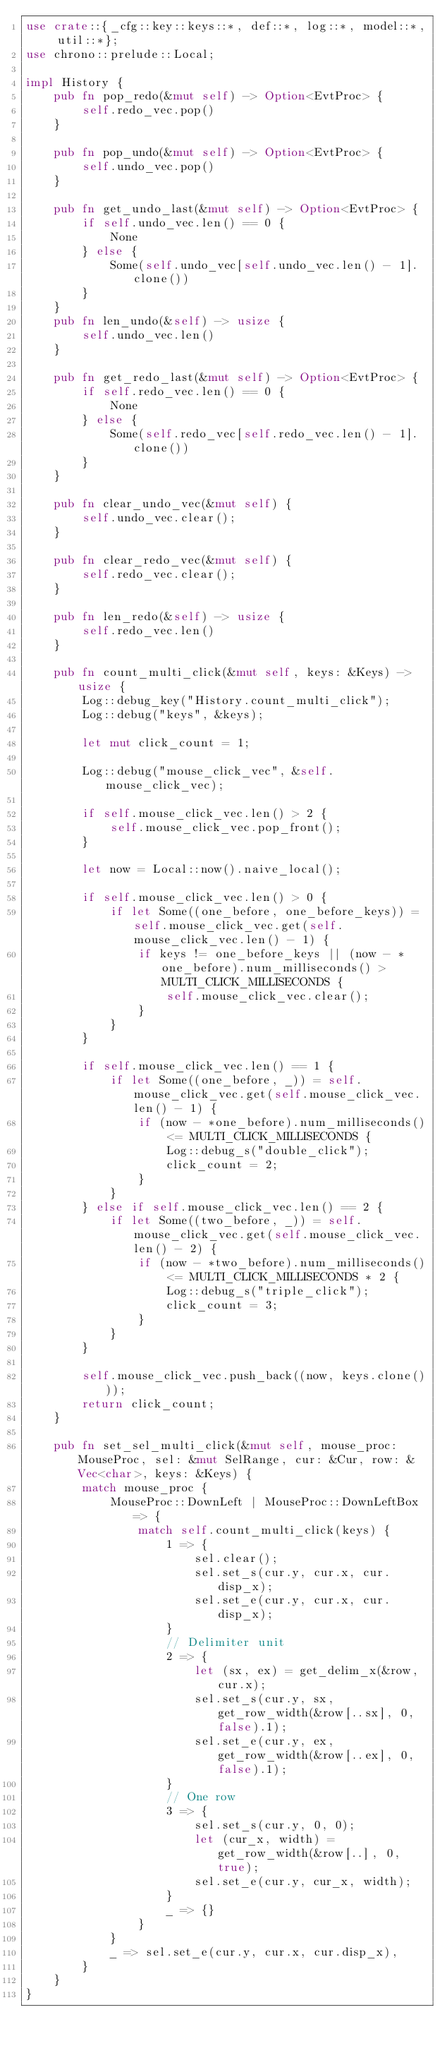<code> <loc_0><loc_0><loc_500><loc_500><_Rust_>use crate::{_cfg::key::keys::*, def::*, log::*, model::*, util::*};
use chrono::prelude::Local;

impl History {
    pub fn pop_redo(&mut self) -> Option<EvtProc> {
        self.redo_vec.pop()
    }

    pub fn pop_undo(&mut self) -> Option<EvtProc> {
        self.undo_vec.pop()
    }

    pub fn get_undo_last(&mut self) -> Option<EvtProc> {
        if self.undo_vec.len() == 0 {
            None
        } else {
            Some(self.undo_vec[self.undo_vec.len() - 1].clone())
        }
    }
    pub fn len_undo(&self) -> usize {
        self.undo_vec.len()
    }

    pub fn get_redo_last(&mut self) -> Option<EvtProc> {
        if self.redo_vec.len() == 0 {
            None
        } else {
            Some(self.redo_vec[self.redo_vec.len() - 1].clone())
        }
    }

    pub fn clear_undo_vec(&mut self) {
        self.undo_vec.clear();
    }

    pub fn clear_redo_vec(&mut self) {
        self.redo_vec.clear();
    }

    pub fn len_redo(&self) -> usize {
        self.redo_vec.len()
    }

    pub fn count_multi_click(&mut self, keys: &Keys) -> usize {
        Log::debug_key("History.count_multi_click");
        Log::debug("keys", &keys);

        let mut click_count = 1;

        Log::debug("mouse_click_vec", &self.mouse_click_vec);

        if self.mouse_click_vec.len() > 2 {
            self.mouse_click_vec.pop_front();
        }

        let now = Local::now().naive_local();

        if self.mouse_click_vec.len() > 0 {
            if let Some((one_before, one_before_keys)) = self.mouse_click_vec.get(self.mouse_click_vec.len() - 1) {
                if keys != one_before_keys || (now - *one_before).num_milliseconds() > MULTI_CLICK_MILLISECONDS {
                    self.mouse_click_vec.clear();
                }
            }
        }

        if self.mouse_click_vec.len() == 1 {
            if let Some((one_before, _)) = self.mouse_click_vec.get(self.mouse_click_vec.len() - 1) {
                if (now - *one_before).num_milliseconds() <= MULTI_CLICK_MILLISECONDS {
                    Log::debug_s("double_click");
                    click_count = 2;
                }
            }
        } else if self.mouse_click_vec.len() == 2 {
            if let Some((two_before, _)) = self.mouse_click_vec.get(self.mouse_click_vec.len() - 2) {
                if (now - *two_before).num_milliseconds() <= MULTI_CLICK_MILLISECONDS * 2 {
                    Log::debug_s("triple_click");
                    click_count = 3;
                }
            }
        }

        self.mouse_click_vec.push_back((now, keys.clone()));
        return click_count;
    }

    pub fn set_sel_multi_click(&mut self, mouse_proc: MouseProc, sel: &mut SelRange, cur: &Cur, row: &Vec<char>, keys: &Keys) {
        match mouse_proc {
            MouseProc::DownLeft | MouseProc::DownLeftBox => {
                match self.count_multi_click(keys) {
                    1 => {
                        sel.clear();
                        sel.set_s(cur.y, cur.x, cur.disp_x);
                        sel.set_e(cur.y, cur.x, cur.disp_x);
                    }
                    // Delimiter unit
                    2 => {
                        let (sx, ex) = get_delim_x(&row, cur.x);
                        sel.set_s(cur.y, sx, get_row_width(&row[..sx], 0, false).1);
                        sel.set_e(cur.y, ex, get_row_width(&row[..ex], 0, false).1);
                    }
                    // One row
                    3 => {
                        sel.set_s(cur.y, 0, 0);
                        let (cur_x, width) = get_row_width(&row[..], 0, true);
                        sel.set_e(cur.y, cur_x, width);
                    }
                    _ => {}
                }
            }
            _ => sel.set_e(cur.y, cur.x, cur.disp_x),
        }
    }
}
</code> 